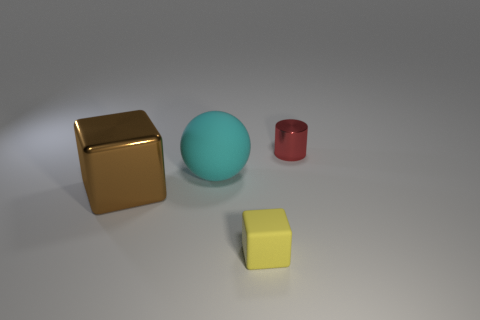Add 3 metal cylinders. How many objects exist? 7 Subtract all cylinders. How many objects are left? 3 Add 4 big matte things. How many big matte things are left? 5 Add 1 cyan matte spheres. How many cyan matte spheres exist? 2 Subtract 0 gray cylinders. How many objects are left? 4 Subtract all red cubes. Subtract all blue spheres. How many cubes are left? 2 Subtract all small brown cubes. Subtract all red things. How many objects are left? 3 